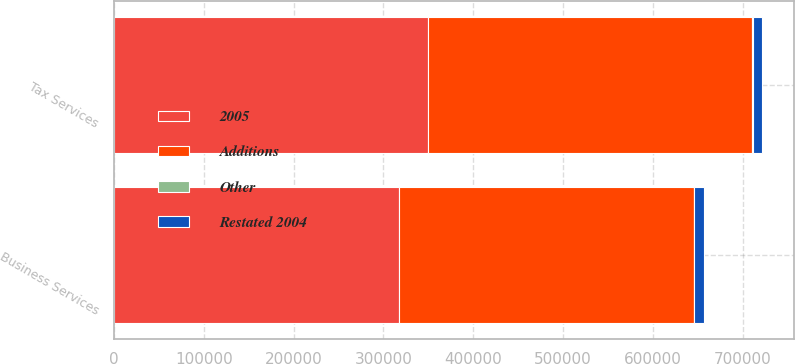<chart> <loc_0><loc_0><loc_500><loc_500><stacked_bar_chart><ecel><fcel>Tax Services<fcel>Business Services<nl><fcel>2005<fcel>350044<fcel>317002<nl><fcel>Restated 2004<fcel>10175<fcel>11513<nl><fcel>Other<fcel>562<fcel>230<nl><fcel>Additions<fcel>360781<fcel>328745<nl></chart> 